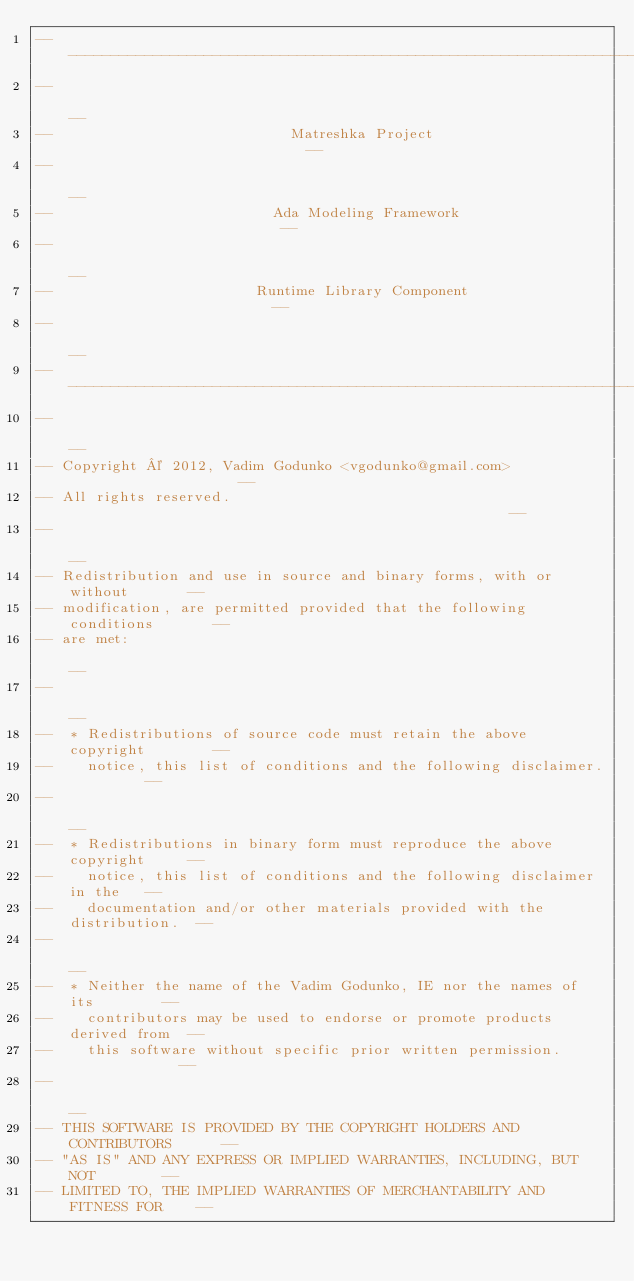<code> <loc_0><loc_0><loc_500><loc_500><_Ada_>------------------------------------------------------------------------------
--                                                                          --
--                            Matreshka Project                             --
--                                                                          --
--                          Ada Modeling Framework                          --
--                                                                          --
--                        Runtime Library Component                         --
--                                                                          --
------------------------------------------------------------------------------
--                                                                          --
-- Copyright © 2012, Vadim Godunko <vgodunko@gmail.com>                     --
-- All rights reserved.                                                     --
--                                                                          --
-- Redistribution and use in source and binary forms, with or without       --
-- modification, are permitted provided that the following conditions       --
-- are met:                                                                 --
--                                                                          --
--  * Redistributions of source code must retain the above copyright        --
--    notice, this list of conditions and the following disclaimer.         --
--                                                                          --
--  * Redistributions in binary form must reproduce the above copyright     --
--    notice, this list of conditions and the following disclaimer in the   --
--    documentation and/or other materials provided with the distribution.  --
--                                                                          --
--  * Neither the name of the Vadim Godunko, IE nor the names of its        --
--    contributors may be used to endorse or promote products derived from  --
--    this software without specific prior written permission.              --
--                                                                          --
-- THIS SOFTWARE IS PROVIDED BY THE COPYRIGHT HOLDERS AND CONTRIBUTORS      --
-- "AS IS" AND ANY EXPRESS OR IMPLIED WARRANTIES, INCLUDING, BUT NOT        --
-- LIMITED TO, THE IMPLIED WARRANTIES OF MERCHANTABILITY AND FITNESS FOR    --</code> 